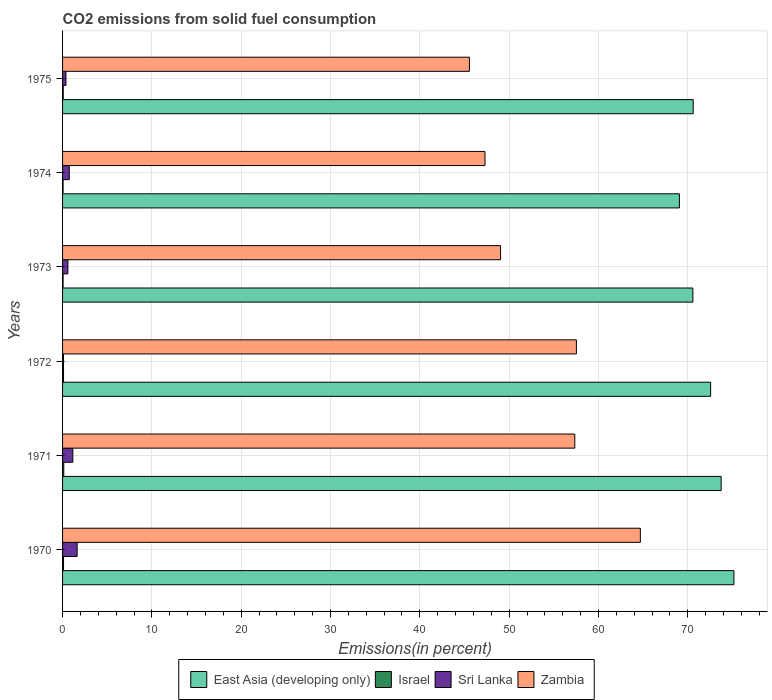How many different coloured bars are there?
Offer a terse response. 4. How many bars are there on the 5th tick from the top?
Make the answer very short. 4. How many bars are there on the 3rd tick from the bottom?
Give a very brief answer. 4. What is the label of the 3rd group of bars from the top?
Make the answer very short. 1973. What is the total CO2 emitted in Sri Lanka in 1972?
Your answer should be very brief. 0.1. Across all years, what is the maximum total CO2 emitted in Israel?
Provide a short and direct response. 0.14. Across all years, what is the minimum total CO2 emitted in Israel?
Offer a terse response. 0.06. In which year was the total CO2 emitted in Israel minimum?
Your answer should be very brief. 1974. What is the total total CO2 emitted in East Asia (developing only) in the graph?
Your answer should be compact. 431.7. What is the difference between the total CO2 emitted in Zambia in 1970 and that in 1975?
Provide a short and direct response. 19.14. What is the difference between the total CO2 emitted in Israel in 1973 and the total CO2 emitted in Sri Lanka in 1975?
Your answer should be compact. -0.32. What is the average total CO2 emitted in East Asia (developing only) per year?
Offer a terse response. 71.95. In the year 1971, what is the difference between the total CO2 emitted in East Asia (developing only) and total CO2 emitted in Israel?
Ensure brevity in your answer.  73.6. What is the ratio of the total CO2 emitted in Israel in 1973 to that in 1974?
Your answer should be very brief. 1.01. Is the total CO2 emitted in Israel in 1973 less than that in 1974?
Keep it short and to the point. No. What is the difference between the highest and the second highest total CO2 emitted in Israel?
Your answer should be compact. 0.02. What is the difference between the highest and the lowest total CO2 emitted in Zambia?
Offer a terse response. 19.14. Is it the case that in every year, the sum of the total CO2 emitted in East Asia (developing only) and total CO2 emitted in Zambia is greater than the sum of total CO2 emitted in Israel and total CO2 emitted in Sri Lanka?
Your response must be concise. Yes. What does the 1st bar from the top in 1973 represents?
Provide a succinct answer. Zambia. What does the 3rd bar from the bottom in 1975 represents?
Keep it short and to the point. Sri Lanka. Are all the bars in the graph horizontal?
Your answer should be compact. Yes. How many years are there in the graph?
Your answer should be very brief. 6. Are the values on the major ticks of X-axis written in scientific E-notation?
Offer a terse response. No. Does the graph contain any zero values?
Make the answer very short. No. Where does the legend appear in the graph?
Offer a very short reply. Bottom center. How many legend labels are there?
Offer a terse response. 4. How are the legend labels stacked?
Your answer should be compact. Horizontal. What is the title of the graph?
Give a very brief answer. CO2 emissions from solid fuel consumption. What is the label or title of the X-axis?
Offer a terse response. Emissions(in percent). What is the label or title of the Y-axis?
Offer a terse response. Years. What is the Emissions(in percent) of East Asia (developing only) in 1970?
Give a very brief answer. 75.17. What is the Emissions(in percent) in Israel in 1970?
Keep it short and to the point. 0.11. What is the Emissions(in percent) of Sri Lanka in 1970?
Offer a terse response. 1.63. What is the Emissions(in percent) of Zambia in 1970?
Your response must be concise. 64.69. What is the Emissions(in percent) in East Asia (developing only) in 1971?
Provide a succinct answer. 73.74. What is the Emissions(in percent) of Israel in 1971?
Provide a short and direct response. 0.14. What is the Emissions(in percent) in Sri Lanka in 1971?
Provide a succinct answer. 1.15. What is the Emissions(in percent) of Zambia in 1971?
Offer a very short reply. 57.35. What is the Emissions(in percent) of East Asia (developing only) in 1972?
Your answer should be compact. 72.56. What is the Emissions(in percent) in Israel in 1972?
Offer a very short reply. 0.11. What is the Emissions(in percent) in Sri Lanka in 1972?
Keep it short and to the point. 0.1. What is the Emissions(in percent) in Zambia in 1972?
Provide a short and direct response. 57.53. What is the Emissions(in percent) of East Asia (developing only) in 1973?
Give a very brief answer. 70.57. What is the Emissions(in percent) in Israel in 1973?
Offer a terse response. 0.06. What is the Emissions(in percent) of Sri Lanka in 1973?
Your answer should be compact. 0.6. What is the Emissions(in percent) in Zambia in 1973?
Make the answer very short. 49.04. What is the Emissions(in percent) in East Asia (developing only) in 1974?
Your response must be concise. 69.06. What is the Emissions(in percent) in Israel in 1974?
Your answer should be very brief. 0.06. What is the Emissions(in percent) in Zambia in 1974?
Keep it short and to the point. 47.29. What is the Emissions(in percent) in East Asia (developing only) in 1975?
Your response must be concise. 70.61. What is the Emissions(in percent) in Israel in 1975?
Your response must be concise. 0.07. What is the Emissions(in percent) of Sri Lanka in 1975?
Provide a succinct answer. 0.38. What is the Emissions(in percent) in Zambia in 1975?
Your answer should be very brief. 45.55. Across all years, what is the maximum Emissions(in percent) of East Asia (developing only)?
Provide a succinct answer. 75.17. Across all years, what is the maximum Emissions(in percent) of Israel?
Ensure brevity in your answer.  0.14. Across all years, what is the maximum Emissions(in percent) in Sri Lanka?
Give a very brief answer. 1.63. Across all years, what is the maximum Emissions(in percent) of Zambia?
Your response must be concise. 64.69. Across all years, what is the minimum Emissions(in percent) of East Asia (developing only)?
Your answer should be compact. 69.06. Across all years, what is the minimum Emissions(in percent) in Israel?
Offer a very short reply. 0.06. Across all years, what is the minimum Emissions(in percent) of Sri Lanka?
Your response must be concise. 0.1. Across all years, what is the minimum Emissions(in percent) in Zambia?
Ensure brevity in your answer.  45.55. What is the total Emissions(in percent) of East Asia (developing only) in the graph?
Keep it short and to the point. 431.7. What is the total Emissions(in percent) in Israel in the graph?
Your answer should be compact. 0.54. What is the total Emissions(in percent) in Sri Lanka in the graph?
Make the answer very short. 4.61. What is the total Emissions(in percent) of Zambia in the graph?
Keep it short and to the point. 321.46. What is the difference between the Emissions(in percent) in East Asia (developing only) in 1970 and that in 1971?
Keep it short and to the point. 1.43. What is the difference between the Emissions(in percent) in Israel in 1970 and that in 1971?
Ensure brevity in your answer.  -0.02. What is the difference between the Emissions(in percent) in Sri Lanka in 1970 and that in 1971?
Give a very brief answer. 0.48. What is the difference between the Emissions(in percent) of Zambia in 1970 and that in 1971?
Your answer should be very brief. 7.34. What is the difference between the Emissions(in percent) in East Asia (developing only) in 1970 and that in 1972?
Provide a short and direct response. 2.61. What is the difference between the Emissions(in percent) of Israel in 1970 and that in 1972?
Your response must be concise. 0. What is the difference between the Emissions(in percent) of Sri Lanka in 1970 and that in 1972?
Offer a very short reply. 1.53. What is the difference between the Emissions(in percent) in Zambia in 1970 and that in 1972?
Ensure brevity in your answer.  7.16. What is the difference between the Emissions(in percent) in East Asia (developing only) in 1970 and that in 1973?
Provide a short and direct response. 4.6. What is the difference between the Emissions(in percent) of Israel in 1970 and that in 1973?
Give a very brief answer. 0.05. What is the difference between the Emissions(in percent) in Sri Lanka in 1970 and that in 1973?
Provide a succinct answer. 1.03. What is the difference between the Emissions(in percent) in Zambia in 1970 and that in 1973?
Ensure brevity in your answer.  15.65. What is the difference between the Emissions(in percent) of East Asia (developing only) in 1970 and that in 1974?
Your response must be concise. 6.11. What is the difference between the Emissions(in percent) in Israel in 1970 and that in 1974?
Ensure brevity in your answer.  0.05. What is the difference between the Emissions(in percent) in Sri Lanka in 1970 and that in 1974?
Provide a succinct answer. 0.88. What is the difference between the Emissions(in percent) of Zambia in 1970 and that in 1974?
Provide a succinct answer. 17.39. What is the difference between the Emissions(in percent) of East Asia (developing only) in 1970 and that in 1975?
Offer a terse response. 4.56. What is the difference between the Emissions(in percent) in Israel in 1970 and that in 1975?
Keep it short and to the point. 0.04. What is the difference between the Emissions(in percent) in Sri Lanka in 1970 and that in 1975?
Provide a short and direct response. 1.25. What is the difference between the Emissions(in percent) in Zambia in 1970 and that in 1975?
Offer a terse response. 19.14. What is the difference between the Emissions(in percent) in East Asia (developing only) in 1971 and that in 1972?
Give a very brief answer. 1.18. What is the difference between the Emissions(in percent) in Israel in 1971 and that in 1972?
Offer a terse response. 0.03. What is the difference between the Emissions(in percent) in Sri Lanka in 1971 and that in 1972?
Offer a terse response. 1.04. What is the difference between the Emissions(in percent) in Zambia in 1971 and that in 1972?
Offer a very short reply. -0.18. What is the difference between the Emissions(in percent) of East Asia (developing only) in 1971 and that in 1973?
Make the answer very short. 3.16. What is the difference between the Emissions(in percent) of Israel in 1971 and that in 1973?
Give a very brief answer. 0.08. What is the difference between the Emissions(in percent) of Sri Lanka in 1971 and that in 1973?
Ensure brevity in your answer.  0.55. What is the difference between the Emissions(in percent) of Zambia in 1971 and that in 1973?
Provide a succinct answer. 8.31. What is the difference between the Emissions(in percent) in East Asia (developing only) in 1971 and that in 1974?
Your answer should be very brief. 4.68. What is the difference between the Emissions(in percent) in Israel in 1971 and that in 1974?
Ensure brevity in your answer.  0.08. What is the difference between the Emissions(in percent) of Sri Lanka in 1971 and that in 1974?
Make the answer very short. 0.4. What is the difference between the Emissions(in percent) in Zambia in 1971 and that in 1974?
Offer a terse response. 10.06. What is the difference between the Emissions(in percent) of East Asia (developing only) in 1971 and that in 1975?
Make the answer very short. 3.13. What is the difference between the Emissions(in percent) of Israel in 1971 and that in 1975?
Make the answer very short. 0.06. What is the difference between the Emissions(in percent) of Sri Lanka in 1971 and that in 1975?
Ensure brevity in your answer.  0.77. What is the difference between the Emissions(in percent) in Zambia in 1971 and that in 1975?
Offer a very short reply. 11.8. What is the difference between the Emissions(in percent) in East Asia (developing only) in 1972 and that in 1973?
Your answer should be compact. 1.99. What is the difference between the Emissions(in percent) of Israel in 1972 and that in 1973?
Your answer should be compact. 0.05. What is the difference between the Emissions(in percent) in Sri Lanka in 1972 and that in 1973?
Your response must be concise. -0.49. What is the difference between the Emissions(in percent) in Zambia in 1972 and that in 1973?
Offer a very short reply. 8.49. What is the difference between the Emissions(in percent) in East Asia (developing only) in 1972 and that in 1974?
Offer a terse response. 3.5. What is the difference between the Emissions(in percent) in Israel in 1972 and that in 1974?
Provide a succinct answer. 0.05. What is the difference between the Emissions(in percent) in Sri Lanka in 1972 and that in 1974?
Give a very brief answer. -0.65. What is the difference between the Emissions(in percent) in Zambia in 1972 and that in 1974?
Your answer should be compact. 10.23. What is the difference between the Emissions(in percent) of East Asia (developing only) in 1972 and that in 1975?
Make the answer very short. 1.95. What is the difference between the Emissions(in percent) in Israel in 1972 and that in 1975?
Keep it short and to the point. 0.03. What is the difference between the Emissions(in percent) of Sri Lanka in 1972 and that in 1975?
Keep it short and to the point. -0.28. What is the difference between the Emissions(in percent) in Zambia in 1972 and that in 1975?
Your answer should be very brief. 11.98. What is the difference between the Emissions(in percent) in East Asia (developing only) in 1973 and that in 1974?
Offer a terse response. 1.51. What is the difference between the Emissions(in percent) in Israel in 1973 and that in 1974?
Provide a short and direct response. 0. What is the difference between the Emissions(in percent) of Sri Lanka in 1973 and that in 1974?
Make the answer very short. -0.15. What is the difference between the Emissions(in percent) in Zambia in 1973 and that in 1974?
Keep it short and to the point. 1.75. What is the difference between the Emissions(in percent) in East Asia (developing only) in 1973 and that in 1975?
Give a very brief answer. -0.04. What is the difference between the Emissions(in percent) of Israel in 1973 and that in 1975?
Offer a terse response. -0.02. What is the difference between the Emissions(in percent) in Sri Lanka in 1973 and that in 1975?
Provide a short and direct response. 0.22. What is the difference between the Emissions(in percent) of Zambia in 1973 and that in 1975?
Offer a terse response. 3.49. What is the difference between the Emissions(in percent) in East Asia (developing only) in 1974 and that in 1975?
Provide a succinct answer. -1.55. What is the difference between the Emissions(in percent) of Israel in 1974 and that in 1975?
Provide a short and direct response. -0.02. What is the difference between the Emissions(in percent) of Sri Lanka in 1974 and that in 1975?
Your answer should be compact. 0.37. What is the difference between the Emissions(in percent) in Zambia in 1974 and that in 1975?
Keep it short and to the point. 1.74. What is the difference between the Emissions(in percent) of East Asia (developing only) in 1970 and the Emissions(in percent) of Israel in 1971?
Provide a succinct answer. 75.03. What is the difference between the Emissions(in percent) in East Asia (developing only) in 1970 and the Emissions(in percent) in Sri Lanka in 1971?
Your answer should be very brief. 74.02. What is the difference between the Emissions(in percent) of East Asia (developing only) in 1970 and the Emissions(in percent) of Zambia in 1971?
Your response must be concise. 17.82. What is the difference between the Emissions(in percent) in Israel in 1970 and the Emissions(in percent) in Sri Lanka in 1971?
Make the answer very short. -1.04. What is the difference between the Emissions(in percent) of Israel in 1970 and the Emissions(in percent) of Zambia in 1971?
Your answer should be very brief. -57.24. What is the difference between the Emissions(in percent) in Sri Lanka in 1970 and the Emissions(in percent) in Zambia in 1971?
Your response must be concise. -55.72. What is the difference between the Emissions(in percent) of East Asia (developing only) in 1970 and the Emissions(in percent) of Israel in 1972?
Keep it short and to the point. 75.06. What is the difference between the Emissions(in percent) of East Asia (developing only) in 1970 and the Emissions(in percent) of Sri Lanka in 1972?
Your response must be concise. 75.06. What is the difference between the Emissions(in percent) of East Asia (developing only) in 1970 and the Emissions(in percent) of Zambia in 1972?
Your response must be concise. 17.64. What is the difference between the Emissions(in percent) in Israel in 1970 and the Emissions(in percent) in Sri Lanka in 1972?
Provide a short and direct response. 0.01. What is the difference between the Emissions(in percent) of Israel in 1970 and the Emissions(in percent) of Zambia in 1972?
Keep it short and to the point. -57.42. What is the difference between the Emissions(in percent) in Sri Lanka in 1970 and the Emissions(in percent) in Zambia in 1972?
Offer a very short reply. -55.9. What is the difference between the Emissions(in percent) in East Asia (developing only) in 1970 and the Emissions(in percent) in Israel in 1973?
Your answer should be compact. 75.11. What is the difference between the Emissions(in percent) of East Asia (developing only) in 1970 and the Emissions(in percent) of Sri Lanka in 1973?
Provide a succinct answer. 74.57. What is the difference between the Emissions(in percent) of East Asia (developing only) in 1970 and the Emissions(in percent) of Zambia in 1973?
Ensure brevity in your answer.  26.13. What is the difference between the Emissions(in percent) of Israel in 1970 and the Emissions(in percent) of Sri Lanka in 1973?
Your answer should be very brief. -0.49. What is the difference between the Emissions(in percent) of Israel in 1970 and the Emissions(in percent) of Zambia in 1973?
Your response must be concise. -48.93. What is the difference between the Emissions(in percent) in Sri Lanka in 1970 and the Emissions(in percent) in Zambia in 1973?
Make the answer very short. -47.41. What is the difference between the Emissions(in percent) of East Asia (developing only) in 1970 and the Emissions(in percent) of Israel in 1974?
Offer a terse response. 75.11. What is the difference between the Emissions(in percent) of East Asia (developing only) in 1970 and the Emissions(in percent) of Sri Lanka in 1974?
Provide a succinct answer. 74.42. What is the difference between the Emissions(in percent) in East Asia (developing only) in 1970 and the Emissions(in percent) in Zambia in 1974?
Ensure brevity in your answer.  27.87. What is the difference between the Emissions(in percent) of Israel in 1970 and the Emissions(in percent) of Sri Lanka in 1974?
Give a very brief answer. -0.64. What is the difference between the Emissions(in percent) of Israel in 1970 and the Emissions(in percent) of Zambia in 1974?
Give a very brief answer. -47.18. What is the difference between the Emissions(in percent) of Sri Lanka in 1970 and the Emissions(in percent) of Zambia in 1974?
Offer a very short reply. -45.66. What is the difference between the Emissions(in percent) of East Asia (developing only) in 1970 and the Emissions(in percent) of Israel in 1975?
Provide a succinct answer. 75.09. What is the difference between the Emissions(in percent) in East Asia (developing only) in 1970 and the Emissions(in percent) in Sri Lanka in 1975?
Your answer should be very brief. 74.79. What is the difference between the Emissions(in percent) of East Asia (developing only) in 1970 and the Emissions(in percent) of Zambia in 1975?
Provide a short and direct response. 29.61. What is the difference between the Emissions(in percent) in Israel in 1970 and the Emissions(in percent) in Sri Lanka in 1975?
Provide a short and direct response. -0.27. What is the difference between the Emissions(in percent) in Israel in 1970 and the Emissions(in percent) in Zambia in 1975?
Your answer should be very brief. -45.44. What is the difference between the Emissions(in percent) of Sri Lanka in 1970 and the Emissions(in percent) of Zambia in 1975?
Your answer should be compact. -43.92. What is the difference between the Emissions(in percent) in East Asia (developing only) in 1971 and the Emissions(in percent) in Israel in 1972?
Offer a terse response. 73.63. What is the difference between the Emissions(in percent) in East Asia (developing only) in 1971 and the Emissions(in percent) in Sri Lanka in 1972?
Offer a terse response. 73.63. What is the difference between the Emissions(in percent) of East Asia (developing only) in 1971 and the Emissions(in percent) of Zambia in 1972?
Give a very brief answer. 16.21. What is the difference between the Emissions(in percent) in Israel in 1971 and the Emissions(in percent) in Sri Lanka in 1972?
Make the answer very short. 0.03. What is the difference between the Emissions(in percent) of Israel in 1971 and the Emissions(in percent) of Zambia in 1972?
Give a very brief answer. -57.39. What is the difference between the Emissions(in percent) of Sri Lanka in 1971 and the Emissions(in percent) of Zambia in 1972?
Your answer should be very brief. -56.38. What is the difference between the Emissions(in percent) of East Asia (developing only) in 1971 and the Emissions(in percent) of Israel in 1973?
Offer a very short reply. 73.68. What is the difference between the Emissions(in percent) in East Asia (developing only) in 1971 and the Emissions(in percent) in Sri Lanka in 1973?
Ensure brevity in your answer.  73.14. What is the difference between the Emissions(in percent) of East Asia (developing only) in 1971 and the Emissions(in percent) of Zambia in 1973?
Offer a very short reply. 24.69. What is the difference between the Emissions(in percent) of Israel in 1971 and the Emissions(in percent) of Sri Lanka in 1973?
Provide a short and direct response. -0.46. What is the difference between the Emissions(in percent) in Israel in 1971 and the Emissions(in percent) in Zambia in 1973?
Provide a short and direct response. -48.91. What is the difference between the Emissions(in percent) in Sri Lanka in 1971 and the Emissions(in percent) in Zambia in 1973?
Make the answer very short. -47.89. What is the difference between the Emissions(in percent) in East Asia (developing only) in 1971 and the Emissions(in percent) in Israel in 1974?
Your answer should be compact. 73.68. What is the difference between the Emissions(in percent) in East Asia (developing only) in 1971 and the Emissions(in percent) in Sri Lanka in 1974?
Ensure brevity in your answer.  72.99. What is the difference between the Emissions(in percent) of East Asia (developing only) in 1971 and the Emissions(in percent) of Zambia in 1974?
Your answer should be very brief. 26.44. What is the difference between the Emissions(in percent) in Israel in 1971 and the Emissions(in percent) in Sri Lanka in 1974?
Ensure brevity in your answer.  -0.61. What is the difference between the Emissions(in percent) in Israel in 1971 and the Emissions(in percent) in Zambia in 1974?
Provide a short and direct response. -47.16. What is the difference between the Emissions(in percent) in Sri Lanka in 1971 and the Emissions(in percent) in Zambia in 1974?
Make the answer very short. -46.15. What is the difference between the Emissions(in percent) in East Asia (developing only) in 1971 and the Emissions(in percent) in Israel in 1975?
Offer a very short reply. 73.66. What is the difference between the Emissions(in percent) in East Asia (developing only) in 1971 and the Emissions(in percent) in Sri Lanka in 1975?
Keep it short and to the point. 73.36. What is the difference between the Emissions(in percent) of East Asia (developing only) in 1971 and the Emissions(in percent) of Zambia in 1975?
Provide a short and direct response. 28.18. What is the difference between the Emissions(in percent) of Israel in 1971 and the Emissions(in percent) of Sri Lanka in 1975?
Ensure brevity in your answer.  -0.24. What is the difference between the Emissions(in percent) in Israel in 1971 and the Emissions(in percent) in Zambia in 1975?
Keep it short and to the point. -45.42. What is the difference between the Emissions(in percent) of Sri Lanka in 1971 and the Emissions(in percent) of Zambia in 1975?
Provide a succinct answer. -44.41. What is the difference between the Emissions(in percent) of East Asia (developing only) in 1972 and the Emissions(in percent) of Israel in 1973?
Give a very brief answer. 72.5. What is the difference between the Emissions(in percent) in East Asia (developing only) in 1972 and the Emissions(in percent) in Sri Lanka in 1973?
Provide a succinct answer. 71.96. What is the difference between the Emissions(in percent) of East Asia (developing only) in 1972 and the Emissions(in percent) of Zambia in 1973?
Keep it short and to the point. 23.52. What is the difference between the Emissions(in percent) in Israel in 1972 and the Emissions(in percent) in Sri Lanka in 1973?
Keep it short and to the point. -0.49. What is the difference between the Emissions(in percent) of Israel in 1972 and the Emissions(in percent) of Zambia in 1973?
Your answer should be very brief. -48.93. What is the difference between the Emissions(in percent) in Sri Lanka in 1972 and the Emissions(in percent) in Zambia in 1973?
Keep it short and to the point. -48.94. What is the difference between the Emissions(in percent) of East Asia (developing only) in 1972 and the Emissions(in percent) of Israel in 1974?
Offer a terse response. 72.5. What is the difference between the Emissions(in percent) of East Asia (developing only) in 1972 and the Emissions(in percent) of Sri Lanka in 1974?
Give a very brief answer. 71.81. What is the difference between the Emissions(in percent) in East Asia (developing only) in 1972 and the Emissions(in percent) in Zambia in 1974?
Your response must be concise. 25.27. What is the difference between the Emissions(in percent) in Israel in 1972 and the Emissions(in percent) in Sri Lanka in 1974?
Provide a short and direct response. -0.64. What is the difference between the Emissions(in percent) of Israel in 1972 and the Emissions(in percent) of Zambia in 1974?
Your answer should be compact. -47.19. What is the difference between the Emissions(in percent) in Sri Lanka in 1972 and the Emissions(in percent) in Zambia in 1974?
Make the answer very short. -47.19. What is the difference between the Emissions(in percent) of East Asia (developing only) in 1972 and the Emissions(in percent) of Israel in 1975?
Offer a terse response. 72.49. What is the difference between the Emissions(in percent) of East Asia (developing only) in 1972 and the Emissions(in percent) of Sri Lanka in 1975?
Your answer should be compact. 72.18. What is the difference between the Emissions(in percent) of East Asia (developing only) in 1972 and the Emissions(in percent) of Zambia in 1975?
Offer a terse response. 27.01. What is the difference between the Emissions(in percent) in Israel in 1972 and the Emissions(in percent) in Sri Lanka in 1975?
Provide a short and direct response. -0.27. What is the difference between the Emissions(in percent) of Israel in 1972 and the Emissions(in percent) of Zambia in 1975?
Provide a short and direct response. -45.44. What is the difference between the Emissions(in percent) in Sri Lanka in 1972 and the Emissions(in percent) in Zambia in 1975?
Make the answer very short. -45.45. What is the difference between the Emissions(in percent) in East Asia (developing only) in 1973 and the Emissions(in percent) in Israel in 1974?
Keep it short and to the point. 70.52. What is the difference between the Emissions(in percent) in East Asia (developing only) in 1973 and the Emissions(in percent) in Sri Lanka in 1974?
Offer a terse response. 69.82. What is the difference between the Emissions(in percent) in East Asia (developing only) in 1973 and the Emissions(in percent) in Zambia in 1974?
Make the answer very short. 23.28. What is the difference between the Emissions(in percent) in Israel in 1973 and the Emissions(in percent) in Sri Lanka in 1974?
Give a very brief answer. -0.69. What is the difference between the Emissions(in percent) of Israel in 1973 and the Emissions(in percent) of Zambia in 1974?
Ensure brevity in your answer.  -47.24. What is the difference between the Emissions(in percent) of Sri Lanka in 1973 and the Emissions(in percent) of Zambia in 1974?
Your answer should be very brief. -46.7. What is the difference between the Emissions(in percent) of East Asia (developing only) in 1973 and the Emissions(in percent) of Israel in 1975?
Ensure brevity in your answer.  70.5. What is the difference between the Emissions(in percent) in East Asia (developing only) in 1973 and the Emissions(in percent) in Sri Lanka in 1975?
Provide a succinct answer. 70.19. What is the difference between the Emissions(in percent) in East Asia (developing only) in 1973 and the Emissions(in percent) in Zambia in 1975?
Provide a short and direct response. 25.02. What is the difference between the Emissions(in percent) in Israel in 1973 and the Emissions(in percent) in Sri Lanka in 1975?
Your response must be concise. -0.32. What is the difference between the Emissions(in percent) in Israel in 1973 and the Emissions(in percent) in Zambia in 1975?
Provide a short and direct response. -45.5. What is the difference between the Emissions(in percent) in Sri Lanka in 1973 and the Emissions(in percent) in Zambia in 1975?
Your answer should be compact. -44.96. What is the difference between the Emissions(in percent) in East Asia (developing only) in 1974 and the Emissions(in percent) in Israel in 1975?
Offer a terse response. 68.99. What is the difference between the Emissions(in percent) of East Asia (developing only) in 1974 and the Emissions(in percent) of Sri Lanka in 1975?
Provide a succinct answer. 68.68. What is the difference between the Emissions(in percent) of East Asia (developing only) in 1974 and the Emissions(in percent) of Zambia in 1975?
Your answer should be compact. 23.51. What is the difference between the Emissions(in percent) in Israel in 1974 and the Emissions(in percent) in Sri Lanka in 1975?
Offer a terse response. -0.32. What is the difference between the Emissions(in percent) of Israel in 1974 and the Emissions(in percent) of Zambia in 1975?
Make the answer very short. -45.5. What is the difference between the Emissions(in percent) of Sri Lanka in 1974 and the Emissions(in percent) of Zambia in 1975?
Keep it short and to the point. -44.8. What is the average Emissions(in percent) of East Asia (developing only) per year?
Keep it short and to the point. 71.95. What is the average Emissions(in percent) in Israel per year?
Ensure brevity in your answer.  0.09. What is the average Emissions(in percent) of Sri Lanka per year?
Make the answer very short. 0.77. What is the average Emissions(in percent) in Zambia per year?
Your answer should be compact. 53.58. In the year 1970, what is the difference between the Emissions(in percent) in East Asia (developing only) and Emissions(in percent) in Israel?
Your answer should be compact. 75.06. In the year 1970, what is the difference between the Emissions(in percent) of East Asia (developing only) and Emissions(in percent) of Sri Lanka?
Offer a terse response. 73.54. In the year 1970, what is the difference between the Emissions(in percent) of East Asia (developing only) and Emissions(in percent) of Zambia?
Offer a very short reply. 10.48. In the year 1970, what is the difference between the Emissions(in percent) of Israel and Emissions(in percent) of Sri Lanka?
Make the answer very short. -1.52. In the year 1970, what is the difference between the Emissions(in percent) in Israel and Emissions(in percent) in Zambia?
Make the answer very short. -64.58. In the year 1970, what is the difference between the Emissions(in percent) in Sri Lanka and Emissions(in percent) in Zambia?
Ensure brevity in your answer.  -63.06. In the year 1971, what is the difference between the Emissions(in percent) in East Asia (developing only) and Emissions(in percent) in Israel?
Keep it short and to the point. 73.6. In the year 1971, what is the difference between the Emissions(in percent) in East Asia (developing only) and Emissions(in percent) in Sri Lanka?
Give a very brief answer. 72.59. In the year 1971, what is the difference between the Emissions(in percent) in East Asia (developing only) and Emissions(in percent) in Zambia?
Your response must be concise. 16.39. In the year 1971, what is the difference between the Emissions(in percent) of Israel and Emissions(in percent) of Sri Lanka?
Give a very brief answer. -1.01. In the year 1971, what is the difference between the Emissions(in percent) in Israel and Emissions(in percent) in Zambia?
Your answer should be compact. -57.21. In the year 1971, what is the difference between the Emissions(in percent) of Sri Lanka and Emissions(in percent) of Zambia?
Provide a short and direct response. -56.2. In the year 1972, what is the difference between the Emissions(in percent) in East Asia (developing only) and Emissions(in percent) in Israel?
Give a very brief answer. 72.45. In the year 1972, what is the difference between the Emissions(in percent) in East Asia (developing only) and Emissions(in percent) in Sri Lanka?
Provide a short and direct response. 72.46. In the year 1972, what is the difference between the Emissions(in percent) in East Asia (developing only) and Emissions(in percent) in Zambia?
Offer a very short reply. 15.03. In the year 1972, what is the difference between the Emissions(in percent) of Israel and Emissions(in percent) of Sri Lanka?
Provide a short and direct response. 0. In the year 1972, what is the difference between the Emissions(in percent) of Israel and Emissions(in percent) of Zambia?
Offer a terse response. -57.42. In the year 1972, what is the difference between the Emissions(in percent) of Sri Lanka and Emissions(in percent) of Zambia?
Keep it short and to the point. -57.43. In the year 1973, what is the difference between the Emissions(in percent) of East Asia (developing only) and Emissions(in percent) of Israel?
Your response must be concise. 70.51. In the year 1973, what is the difference between the Emissions(in percent) in East Asia (developing only) and Emissions(in percent) in Sri Lanka?
Provide a succinct answer. 69.98. In the year 1973, what is the difference between the Emissions(in percent) of East Asia (developing only) and Emissions(in percent) of Zambia?
Your response must be concise. 21.53. In the year 1973, what is the difference between the Emissions(in percent) in Israel and Emissions(in percent) in Sri Lanka?
Make the answer very short. -0.54. In the year 1973, what is the difference between the Emissions(in percent) of Israel and Emissions(in percent) of Zambia?
Give a very brief answer. -48.98. In the year 1973, what is the difference between the Emissions(in percent) in Sri Lanka and Emissions(in percent) in Zambia?
Your response must be concise. -48.45. In the year 1974, what is the difference between the Emissions(in percent) in East Asia (developing only) and Emissions(in percent) in Israel?
Ensure brevity in your answer.  69. In the year 1974, what is the difference between the Emissions(in percent) of East Asia (developing only) and Emissions(in percent) of Sri Lanka?
Your answer should be very brief. 68.31. In the year 1974, what is the difference between the Emissions(in percent) of East Asia (developing only) and Emissions(in percent) of Zambia?
Your response must be concise. 21.77. In the year 1974, what is the difference between the Emissions(in percent) in Israel and Emissions(in percent) in Sri Lanka?
Ensure brevity in your answer.  -0.69. In the year 1974, what is the difference between the Emissions(in percent) of Israel and Emissions(in percent) of Zambia?
Make the answer very short. -47.24. In the year 1974, what is the difference between the Emissions(in percent) in Sri Lanka and Emissions(in percent) in Zambia?
Offer a terse response. -46.54. In the year 1975, what is the difference between the Emissions(in percent) in East Asia (developing only) and Emissions(in percent) in Israel?
Offer a terse response. 70.53. In the year 1975, what is the difference between the Emissions(in percent) in East Asia (developing only) and Emissions(in percent) in Sri Lanka?
Your answer should be compact. 70.23. In the year 1975, what is the difference between the Emissions(in percent) of East Asia (developing only) and Emissions(in percent) of Zambia?
Offer a terse response. 25.05. In the year 1975, what is the difference between the Emissions(in percent) of Israel and Emissions(in percent) of Sri Lanka?
Your response must be concise. -0.31. In the year 1975, what is the difference between the Emissions(in percent) in Israel and Emissions(in percent) in Zambia?
Ensure brevity in your answer.  -45.48. In the year 1975, what is the difference between the Emissions(in percent) in Sri Lanka and Emissions(in percent) in Zambia?
Give a very brief answer. -45.17. What is the ratio of the Emissions(in percent) in East Asia (developing only) in 1970 to that in 1971?
Give a very brief answer. 1.02. What is the ratio of the Emissions(in percent) of Israel in 1970 to that in 1971?
Your answer should be very brief. 0.82. What is the ratio of the Emissions(in percent) of Sri Lanka in 1970 to that in 1971?
Offer a very short reply. 1.42. What is the ratio of the Emissions(in percent) in Zambia in 1970 to that in 1971?
Offer a terse response. 1.13. What is the ratio of the Emissions(in percent) in East Asia (developing only) in 1970 to that in 1972?
Provide a short and direct response. 1.04. What is the ratio of the Emissions(in percent) in Israel in 1970 to that in 1972?
Ensure brevity in your answer.  1.02. What is the ratio of the Emissions(in percent) in Sri Lanka in 1970 to that in 1972?
Your response must be concise. 15.76. What is the ratio of the Emissions(in percent) of Zambia in 1970 to that in 1972?
Your response must be concise. 1.12. What is the ratio of the Emissions(in percent) of East Asia (developing only) in 1970 to that in 1973?
Offer a very short reply. 1.07. What is the ratio of the Emissions(in percent) of Israel in 1970 to that in 1973?
Your response must be concise. 1.94. What is the ratio of the Emissions(in percent) in Sri Lanka in 1970 to that in 1973?
Make the answer very short. 2.73. What is the ratio of the Emissions(in percent) in Zambia in 1970 to that in 1973?
Your answer should be very brief. 1.32. What is the ratio of the Emissions(in percent) in East Asia (developing only) in 1970 to that in 1974?
Offer a terse response. 1.09. What is the ratio of the Emissions(in percent) in Israel in 1970 to that in 1974?
Your answer should be very brief. 1.96. What is the ratio of the Emissions(in percent) of Sri Lanka in 1970 to that in 1974?
Provide a short and direct response. 2.17. What is the ratio of the Emissions(in percent) of Zambia in 1970 to that in 1974?
Give a very brief answer. 1.37. What is the ratio of the Emissions(in percent) in East Asia (developing only) in 1970 to that in 1975?
Ensure brevity in your answer.  1.06. What is the ratio of the Emissions(in percent) of Israel in 1970 to that in 1975?
Keep it short and to the point. 1.48. What is the ratio of the Emissions(in percent) of Sri Lanka in 1970 to that in 1975?
Provide a succinct answer. 4.29. What is the ratio of the Emissions(in percent) in Zambia in 1970 to that in 1975?
Give a very brief answer. 1.42. What is the ratio of the Emissions(in percent) of East Asia (developing only) in 1971 to that in 1972?
Provide a succinct answer. 1.02. What is the ratio of the Emissions(in percent) in Israel in 1971 to that in 1972?
Give a very brief answer. 1.25. What is the ratio of the Emissions(in percent) in Sri Lanka in 1971 to that in 1972?
Your response must be concise. 11.08. What is the ratio of the Emissions(in percent) in Zambia in 1971 to that in 1972?
Give a very brief answer. 1. What is the ratio of the Emissions(in percent) of East Asia (developing only) in 1971 to that in 1973?
Your response must be concise. 1.04. What is the ratio of the Emissions(in percent) of Israel in 1971 to that in 1973?
Offer a very short reply. 2.38. What is the ratio of the Emissions(in percent) of Sri Lanka in 1971 to that in 1973?
Your response must be concise. 1.92. What is the ratio of the Emissions(in percent) in Zambia in 1971 to that in 1973?
Your response must be concise. 1.17. What is the ratio of the Emissions(in percent) of East Asia (developing only) in 1971 to that in 1974?
Offer a terse response. 1.07. What is the ratio of the Emissions(in percent) of Israel in 1971 to that in 1974?
Your response must be concise. 2.39. What is the ratio of the Emissions(in percent) in Sri Lanka in 1971 to that in 1974?
Keep it short and to the point. 1.53. What is the ratio of the Emissions(in percent) in Zambia in 1971 to that in 1974?
Offer a terse response. 1.21. What is the ratio of the Emissions(in percent) of East Asia (developing only) in 1971 to that in 1975?
Offer a terse response. 1.04. What is the ratio of the Emissions(in percent) in Israel in 1971 to that in 1975?
Ensure brevity in your answer.  1.81. What is the ratio of the Emissions(in percent) in Sri Lanka in 1971 to that in 1975?
Offer a terse response. 3.02. What is the ratio of the Emissions(in percent) in Zambia in 1971 to that in 1975?
Provide a succinct answer. 1.26. What is the ratio of the Emissions(in percent) of East Asia (developing only) in 1972 to that in 1973?
Offer a terse response. 1.03. What is the ratio of the Emissions(in percent) of Israel in 1972 to that in 1973?
Offer a very short reply. 1.9. What is the ratio of the Emissions(in percent) in Sri Lanka in 1972 to that in 1973?
Ensure brevity in your answer.  0.17. What is the ratio of the Emissions(in percent) in Zambia in 1972 to that in 1973?
Ensure brevity in your answer.  1.17. What is the ratio of the Emissions(in percent) in East Asia (developing only) in 1972 to that in 1974?
Your answer should be compact. 1.05. What is the ratio of the Emissions(in percent) of Israel in 1972 to that in 1974?
Your response must be concise. 1.91. What is the ratio of the Emissions(in percent) of Sri Lanka in 1972 to that in 1974?
Offer a terse response. 0.14. What is the ratio of the Emissions(in percent) of Zambia in 1972 to that in 1974?
Offer a terse response. 1.22. What is the ratio of the Emissions(in percent) of East Asia (developing only) in 1972 to that in 1975?
Make the answer very short. 1.03. What is the ratio of the Emissions(in percent) of Israel in 1972 to that in 1975?
Ensure brevity in your answer.  1.45. What is the ratio of the Emissions(in percent) in Sri Lanka in 1972 to that in 1975?
Provide a succinct answer. 0.27. What is the ratio of the Emissions(in percent) in Zambia in 1972 to that in 1975?
Keep it short and to the point. 1.26. What is the ratio of the Emissions(in percent) of East Asia (developing only) in 1973 to that in 1974?
Offer a very short reply. 1.02. What is the ratio of the Emissions(in percent) of Israel in 1973 to that in 1974?
Give a very brief answer. 1.01. What is the ratio of the Emissions(in percent) of Sri Lanka in 1973 to that in 1974?
Your response must be concise. 0.8. What is the ratio of the Emissions(in percent) in Zambia in 1973 to that in 1974?
Keep it short and to the point. 1.04. What is the ratio of the Emissions(in percent) in Israel in 1973 to that in 1975?
Give a very brief answer. 0.76. What is the ratio of the Emissions(in percent) of Sri Lanka in 1973 to that in 1975?
Your answer should be very brief. 1.57. What is the ratio of the Emissions(in percent) of Zambia in 1973 to that in 1975?
Provide a short and direct response. 1.08. What is the ratio of the Emissions(in percent) of East Asia (developing only) in 1974 to that in 1975?
Offer a terse response. 0.98. What is the ratio of the Emissions(in percent) of Israel in 1974 to that in 1975?
Keep it short and to the point. 0.76. What is the ratio of the Emissions(in percent) in Sri Lanka in 1974 to that in 1975?
Keep it short and to the point. 1.98. What is the ratio of the Emissions(in percent) in Zambia in 1974 to that in 1975?
Your response must be concise. 1.04. What is the difference between the highest and the second highest Emissions(in percent) of East Asia (developing only)?
Provide a short and direct response. 1.43. What is the difference between the highest and the second highest Emissions(in percent) in Israel?
Make the answer very short. 0.02. What is the difference between the highest and the second highest Emissions(in percent) of Sri Lanka?
Ensure brevity in your answer.  0.48. What is the difference between the highest and the second highest Emissions(in percent) of Zambia?
Make the answer very short. 7.16. What is the difference between the highest and the lowest Emissions(in percent) of East Asia (developing only)?
Make the answer very short. 6.11. What is the difference between the highest and the lowest Emissions(in percent) in Israel?
Your answer should be very brief. 0.08. What is the difference between the highest and the lowest Emissions(in percent) of Sri Lanka?
Ensure brevity in your answer.  1.53. What is the difference between the highest and the lowest Emissions(in percent) in Zambia?
Make the answer very short. 19.14. 